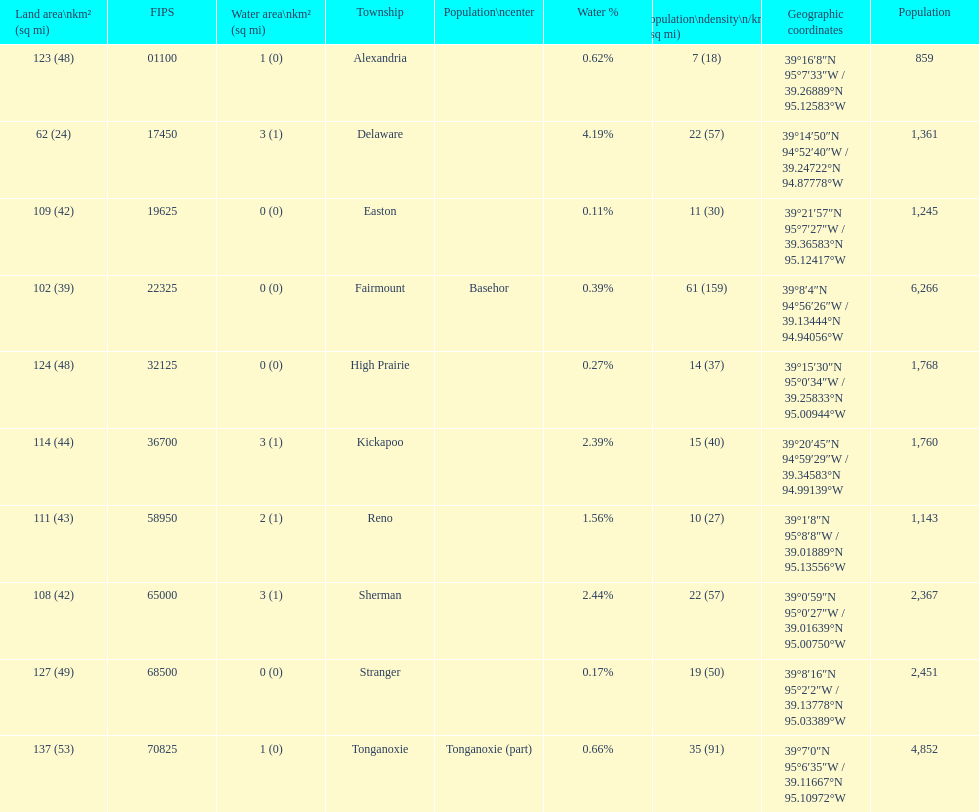How many townships are in leavenworth county? 10. 